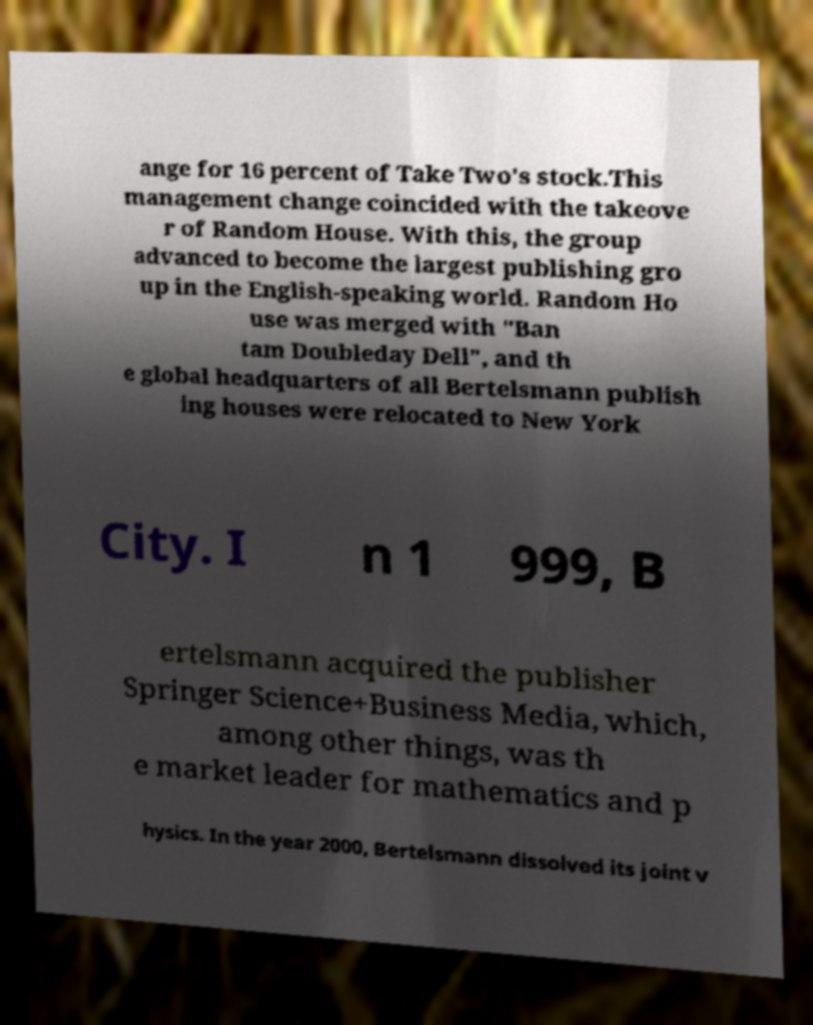Please read and relay the text visible in this image. What does it say? ange for 16 percent of Take Two's stock.This management change coincided with the takeove r of Random House. With this, the group advanced to become the largest publishing gro up in the English-speaking world. Random Ho use was merged with "Ban tam Doubleday Dell", and th e global headquarters of all Bertelsmann publish ing houses were relocated to New York City. I n 1 999, B ertelsmann acquired the publisher Springer Science+Business Media, which, among other things, was th e market leader for mathematics and p hysics. In the year 2000, Bertelsmann dissolved its joint v 